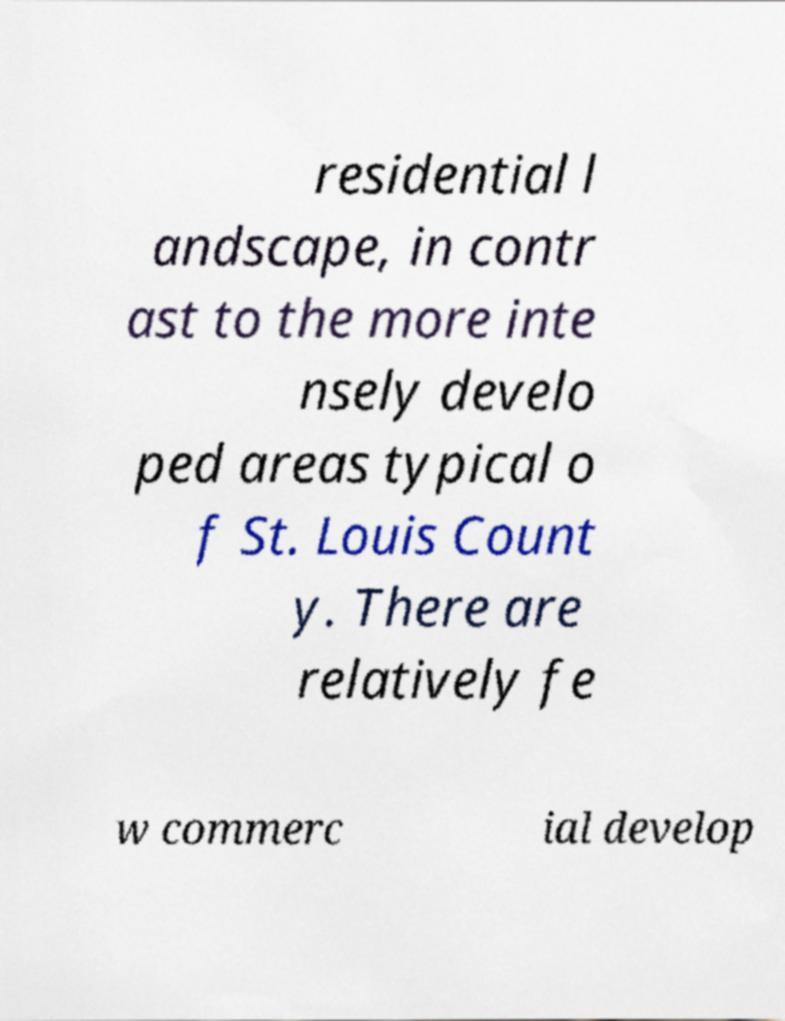There's text embedded in this image that I need extracted. Can you transcribe it verbatim? residential l andscape, in contr ast to the more inte nsely develo ped areas typical o f St. Louis Count y. There are relatively fe w commerc ial develop 